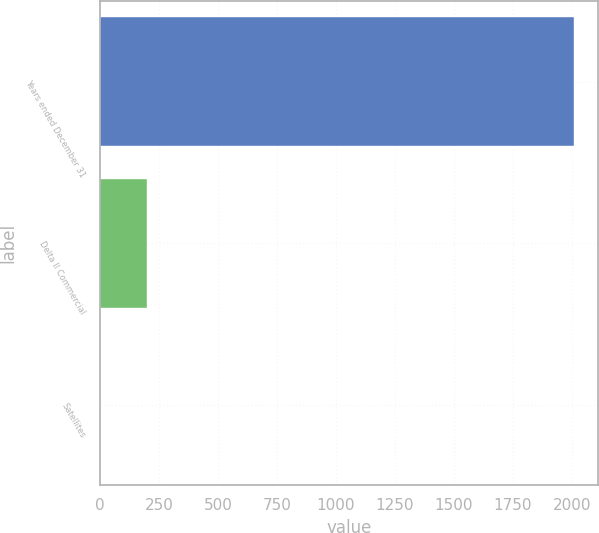Convert chart. <chart><loc_0><loc_0><loc_500><loc_500><bar_chart><fcel>Years ended December 31<fcel>Delta II Commercial<fcel>Satellites<nl><fcel>2008<fcel>201.7<fcel>1<nl></chart> 